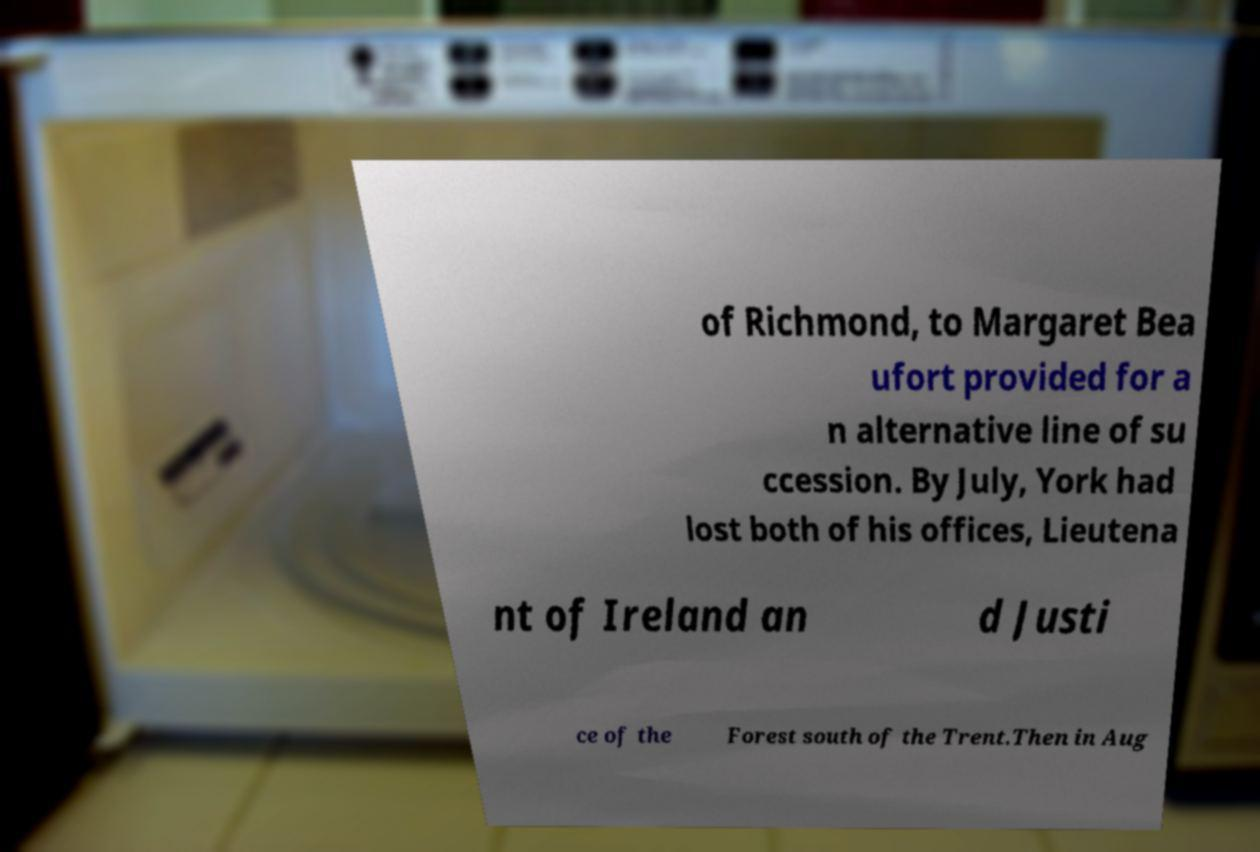Please identify and transcribe the text found in this image. of Richmond, to Margaret Bea ufort provided for a n alternative line of su ccession. By July, York had lost both of his offices, Lieutena nt of Ireland an d Justi ce of the Forest south of the Trent.Then in Aug 